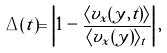Convert formula to latex. <formula><loc_0><loc_0><loc_500><loc_500>\Delta ( t ) = \left | 1 - \frac { \langle v _ { x } ( y , t ) \rangle } { \langle v _ { x } ( y ) \rangle _ { t } } \right | ,</formula> 